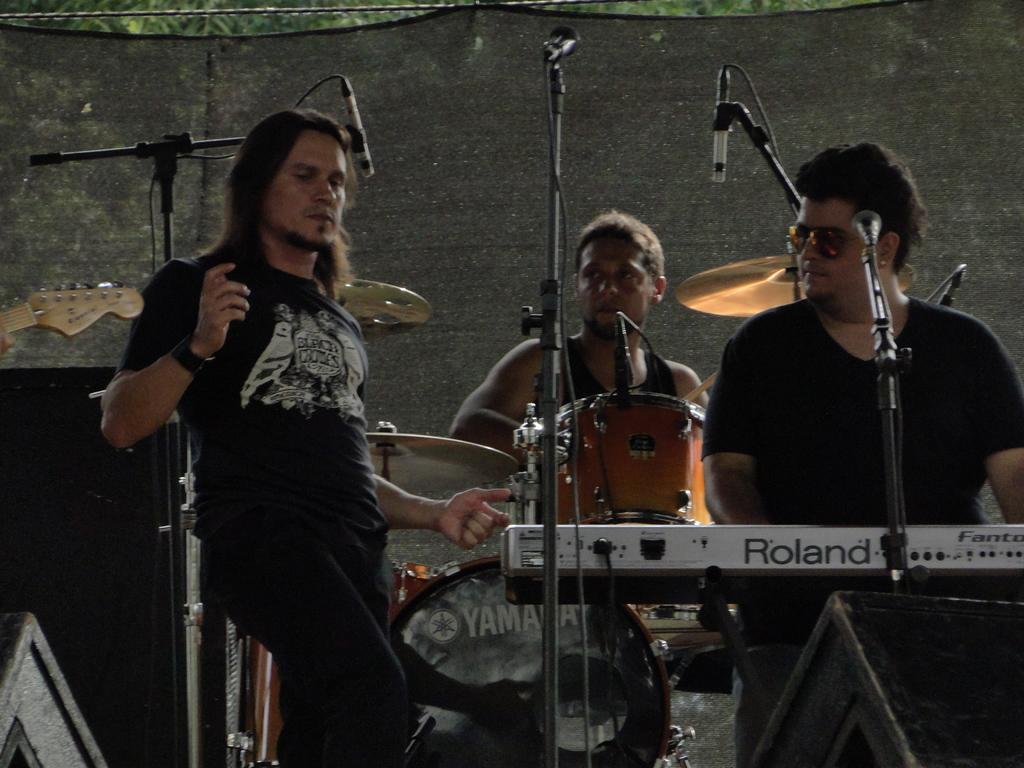Describe this image in one or two sentences. In this image I can see three men are standing. Here I can see he is wearing a shades and all of them are wearing black dress. I can also see few mice and few musical instruments. 